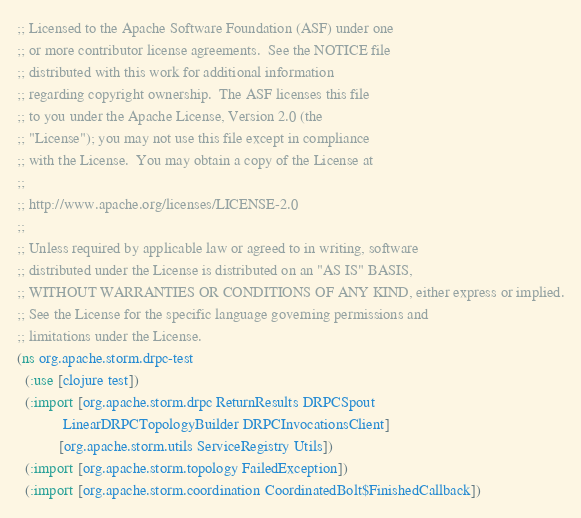<code> <loc_0><loc_0><loc_500><loc_500><_Clojure_>;; Licensed to the Apache Software Foundation (ASF) under one
;; or more contributor license agreements.  See the NOTICE file
;; distributed with this work for additional information
;; regarding copyright ownership.  The ASF licenses this file
;; to you under the Apache License, Version 2.0 (the
;; "License"); you may not use this file except in compliance
;; with the License.  You may obtain a copy of the License at
;;
;; http://www.apache.org/licenses/LICENSE-2.0
;;
;; Unless required by applicable law or agreed to in writing, software
;; distributed under the License is distributed on an "AS IS" BASIS,
;; WITHOUT WARRANTIES OR CONDITIONS OF ANY KIND, either express or implied.
;; See the License for the specific language governing permissions and
;; limitations under the License.
(ns org.apache.storm.drpc-test
  (:use [clojure test])
  (:import [org.apache.storm.drpc ReturnResults DRPCSpout
            LinearDRPCTopologyBuilder DRPCInvocationsClient]
           [org.apache.storm.utils ServiceRegistry Utils])
  (:import [org.apache.storm.topology FailedException])
  (:import [org.apache.storm.coordination CoordinatedBolt$FinishedCallback])</code> 